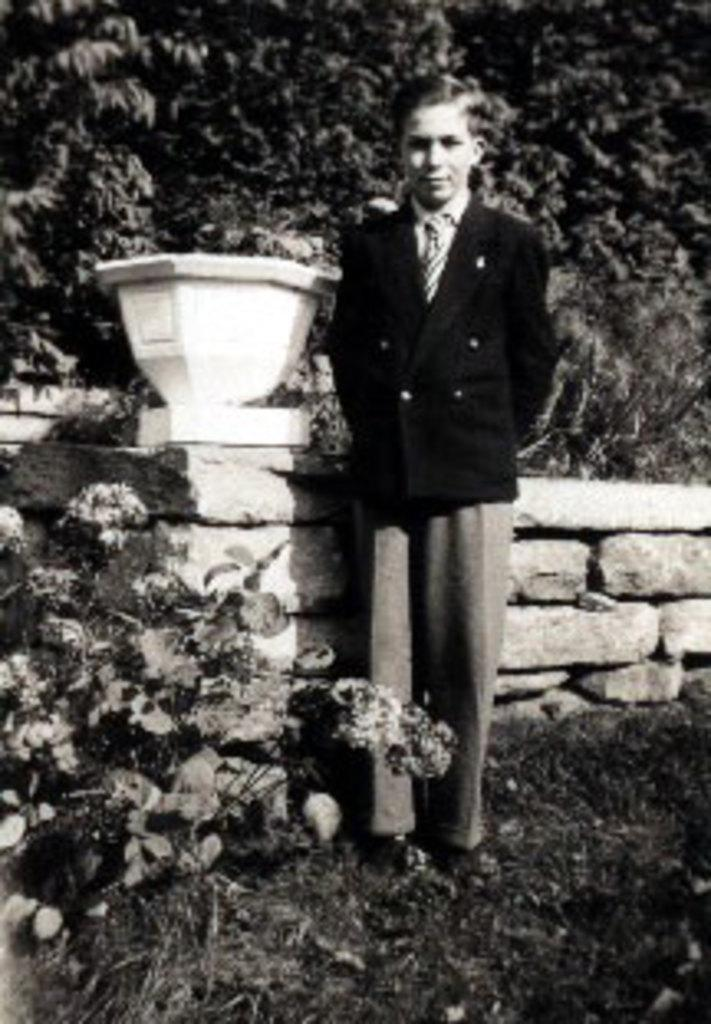What is the color scheme of the image? The image is black and white. Who is present in the image? There is a man in the image. What is the man wearing? The man is wearing a blazer and a tie. What is the man's position in the image? The man is standing on the ground. What objects can be seen in the image? There is a pot and flowers in the image. What can be seen in the background of the image? There are trees in the background of the image. How many women are serving the man in the image? There are no women present in the image, nor is there any indication of serving or assistance. What shape is the pot in the image? The shape of the pot cannot be determined from the image, as it is not described in the provided facts. 